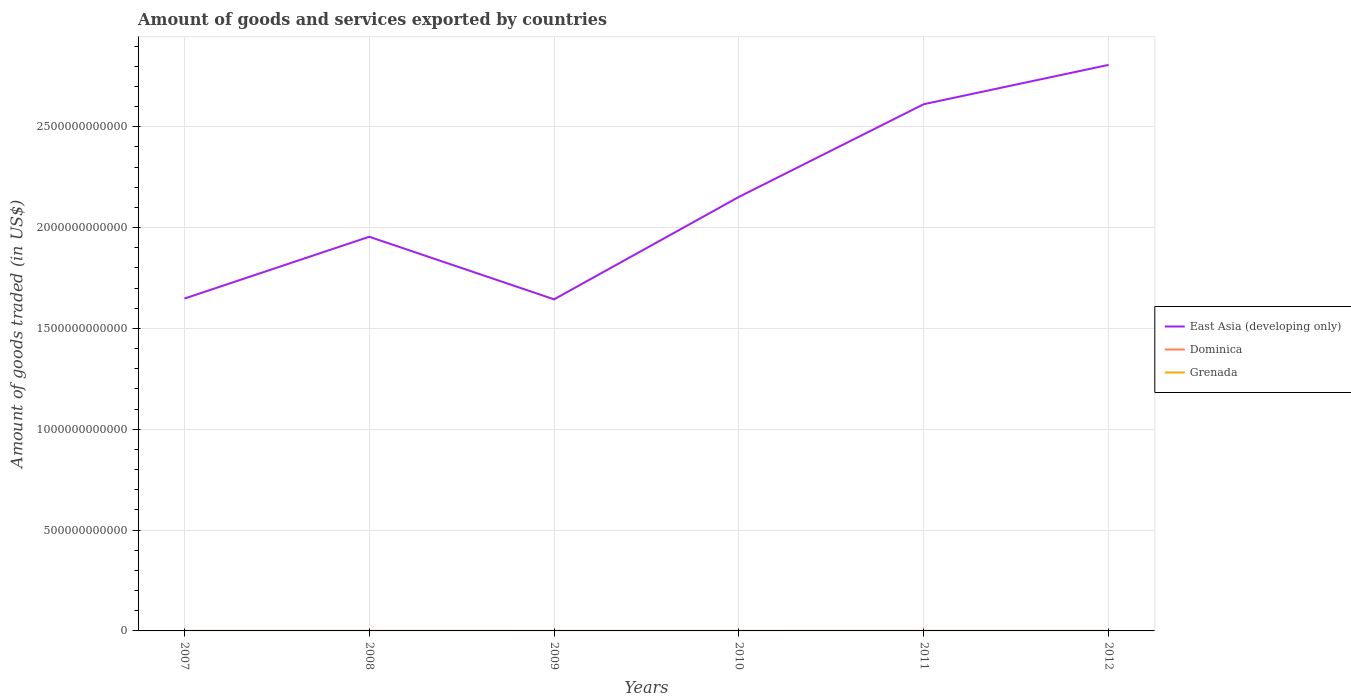Does the line corresponding to East Asia (developing only) intersect with the line corresponding to Grenada?
Your answer should be very brief. No. Is the number of lines equal to the number of legend labels?
Ensure brevity in your answer.  Yes. Across all years, what is the maximum total amount of goods and services exported in Dominica?
Offer a terse response. 3.62e+07. In which year was the total amount of goods and services exported in Dominica maximum?
Give a very brief answer. 2011. What is the total total amount of goods and services exported in East Asia (developing only) in the graph?
Offer a terse response. -4.60e+11. What is the difference between the highest and the second highest total amount of goods and services exported in Grenada?
Give a very brief answer. 1.17e+07. How many lines are there?
Offer a terse response. 3. How many years are there in the graph?
Your answer should be very brief. 6. What is the difference between two consecutive major ticks on the Y-axis?
Make the answer very short. 5.00e+11. Are the values on the major ticks of Y-axis written in scientific E-notation?
Provide a short and direct response. No. How are the legend labels stacked?
Your answer should be very brief. Vertical. What is the title of the graph?
Make the answer very short. Amount of goods and services exported by countries. Does "North America" appear as one of the legend labels in the graph?
Offer a terse response. No. What is the label or title of the Y-axis?
Ensure brevity in your answer.  Amount of goods traded (in US$). What is the Amount of goods traded (in US$) in East Asia (developing only) in 2007?
Provide a short and direct response. 1.65e+12. What is the Amount of goods traded (in US$) in Dominica in 2007?
Provide a succinct answer. 3.90e+07. What is the Amount of goods traded (in US$) of Grenada in 2007?
Offer a terse response. 4.07e+07. What is the Amount of goods traded (in US$) in East Asia (developing only) in 2008?
Your answer should be compact. 1.95e+12. What is the Amount of goods traded (in US$) of Dominica in 2008?
Offer a terse response. 4.39e+07. What is the Amount of goods traded (in US$) of Grenada in 2008?
Your answer should be very brief. 4.05e+07. What is the Amount of goods traded (in US$) of East Asia (developing only) in 2009?
Your response must be concise. 1.64e+12. What is the Amount of goods traded (in US$) in Dominica in 2009?
Make the answer very short. 3.68e+07. What is the Amount of goods traded (in US$) in Grenada in 2009?
Your answer should be compact. 3.53e+07. What is the Amount of goods traded (in US$) in East Asia (developing only) in 2010?
Offer a terse response. 2.15e+12. What is the Amount of goods traded (in US$) of Dominica in 2010?
Provide a short and direct response. 3.72e+07. What is the Amount of goods traded (in US$) of Grenada in 2010?
Your response must be concise. 3.11e+07. What is the Amount of goods traded (in US$) in East Asia (developing only) in 2011?
Keep it short and to the point. 2.61e+12. What is the Amount of goods traded (in US$) of Dominica in 2011?
Make the answer very short. 3.62e+07. What is the Amount of goods traded (in US$) of Grenada in 2011?
Your answer should be very brief. 3.72e+07. What is the Amount of goods traded (in US$) of East Asia (developing only) in 2012?
Make the answer very short. 2.81e+12. What is the Amount of goods traded (in US$) of Dominica in 2012?
Offer a terse response. 3.86e+07. What is the Amount of goods traded (in US$) of Grenada in 2012?
Offer a very short reply. 4.28e+07. Across all years, what is the maximum Amount of goods traded (in US$) in East Asia (developing only)?
Offer a very short reply. 2.81e+12. Across all years, what is the maximum Amount of goods traded (in US$) in Dominica?
Your answer should be very brief. 4.39e+07. Across all years, what is the maximum Amount of goods traded (in US$) of Grenada?
Your answer should be very brief. 4.28e+07. Across all years, what is the minimum Amount of goods traded (in US$) of East Asia (developing only)?
Your answer should be very brief. 1.64e+12. Across all years, what is the minimum Amount of goods traded (in US$) of Dominica?
Your answer should be very brief. 3.62e+07. Across all years, what is the minimum Amount of goods traded (in US$) in Grenada?
Make the answer very short. 3.11e+07. What is the total Amount of goods traded (in US$) in East Asia (developing only) in the graph?
Your answer should be compact. 1.28e+13. What is the total Amount of goods traded (in US$) in Dominica in the graph?
Your response must be concise. 2.32e+08. What is the total Amount of goods traded (in US$) of Grenada in the graph?
Your answer should be compact. 2.28e+08. What is the difference between the Amount of goods traded (in US$) of East Asia (developing only) in 2007 and that in 2008?
Give a very brief answer. -3.07e+11. What is the difference between the Amount of goods traded (in US$) in Dominica in 2007 and that in 2008?
Offer a terse response. -4.87e+06. What is the difference between the Amount of goods traded (in US$) in Grenada in 2007 and that in 2008?
Provide a succinct answer. 2.65e+05. What is the difference between the Amount of goods traded (in US$) in East Asia (developing only) in 2007 and that in 2009?
Ensure brevity in your answer.  3.78e+09. What is the difference between the Amount of goods traded (in US$) in Dominica in 2007 and that in 2009?
Provide a succinct answer. 2.20e+06. What is the difference between the Amount of goods traded (in US$) in Grenada in 2007 and that in 2009?
Offer a very short reply. 5.44e+06. What is the difference between the Amount of goods traded (in US$) of East Asia (developing only) in 2007 and that in 2010?
Provide a short and direct response. -5.04e+11. What is the difference between the Amount of goods traded (in US$) in Dominica in 2007 and that in 2010?
Provide a short and direct response. 1.77e+06. What is the difference between the Amount of goods traded (in US$) in Grenada in 2007 and that in 2010?
Provide a succinct answer. 9.61e+06. What is the difference between the Amount of goods traded (in US$) in East Asia (developing only) in 2007 and that in 2011?
Provide a short and direct response. -9.64e+11. What is the difference between the Amount of goods traded (in US$) in Dominica in 2007 and that in 2011?
Provide a succinct answer. 2.85e+06. What is the difference between the Amount of goods traded (in US$) in Grenada in 2007 and that in 2011?
Your response must be concise. 3.58e+06. What is the difference between the Amount of goods traded (in US$) of East Asia (developing only) in 2007 and that in 2012?
Your response must be concise. -1.16e+12. What is the difference between the Amount of goods traded (in US$) in Dominica in 2007 and that in 2012?
Keep it short and to the point. 4.24e+05. What is the difference between the Amount of goods traded (in US$) in Grenada in 2007 and that in 2012?
Your answer should be compact. -2.08e+06. What is the difference between the Amount of goods traded (in US$) of East Asia (developing only) in 2008 and that in 2009?
Provide a succinct answer. 3.10e+11. What is the difference between the Amount of goods traded (in US$) of Dominica in 2008 and that in 2009?
Keep it short and to the point. 7.07e+06. What is the difference between the Amount of goods traded (in US$) of Grenada in 2008 and that in 2009?
Make the answer very short. 5.17e+06. What is the difference between the Amount of goods traded (in US$) of East Asia (developing only) in 2008 and that in 2010?
Offer a terse response. -1.98e+11. What is the difference between the Amount of goods traded (in US$) of Dominica in 2008 and that in 2010?
Provide a succinct answer. 6.64e+06. What is the difference between the Amount of goods traded (in US$) in Grenada in 2008 and that in 2010?
Ensure brevity in your answer.  9.34e+06. What is the difference between the Amount of goods traded (in US$) in East Asia (developing only) in 2008 and that in 2011?
Provide a short and direct response. -6.57e+11. What is the difference between the Amount of goods traded (in US$) in Dominica in 2008 and that in 2011?
Ensure brevity in your answer.  7.72e+06. What is the difference between the Amount of goods traded (in US$) in Grenada in 2008 and that in 2011?
Your response must be concise. 3.31e+06. What is the difference between the Amount of goods traded (in US$) of East Asia (developing only) in 2008 and that in 2012?
Provide a succinct answer. -8.52e+11. What is the difference between the Amount of goods traded (in US$) in Dominica in 2008 and that in 2012?
Ensure brevity in your answer.  5.29e+06. What is the difference between the Amount of goods traded (in US$) of Grenada in 2008 and that in 2012?
Offer a very short reply. -2.35e+06. What is the difference between the Amount of goods traded (in US$) of East Asia (developing only) in 2009 and that in 2010?
Your response must be concise. -5.08e+11. What is the difference between the Amount of goods traded (in US$) in Dominica in 2009 and that in 2010?
Your answer should be compact. -4.28e+05. What is the difference between the Amount of goods traded (in US$) in Grenada in 2009 and that in 2010?
Offer a terse response. 4.17e+06. What is the difference between the Amount of goods traded (in US$) of East Asia (developing only) in 2009 and that in 2011?
Provide a short and direct response. -9.68e+11. What is the difference between the Amount of goods traded (in US$) of Dominica in 2009 and that in 2011?
Keep it short and to the point. 6.46e+05. What is the difference between the Amount of goods traded (in US$) in Grenada in 2009 and that in 2011?
Your answer should be very brief. -1.86e+06. What is the difference between the Amount of goods traded (in US$) of East Asia (developing only) in 2009 and that in 2012?
Offer a terse response. -1.16e+12. What is the difference between the Amount of goods traded (in US$) of Dominica in 2009 and that in 2012?
Provide a succinct answer. -1.78e+06. What is the difference between the Amount of goods traded (in US$) in Grenada in 2009 and that in 2012?
Provide a short and direct response. -7.52e+06. What is the difference between the Amount of goods traded (in US$) of East Asia (developing only) in 2010 and that in 2011?
Provide a succinct answer. -4.60e+11. What is the difference between the Amount of goods traded (in US$) in Dominica in 2010 and that in 2011?
Ensure brevity in your answer.  1.07e+06. What is the difference between the Amount of goods traded (in US$) of Grenada in 2010 and that in 2011?
Provide a succinct answer. -6.03e+06. What is the difference between the Amount of goods traded (in US$) in East Asia (developing only) in 2010 and that in 2012?
Your answer should be compact. -6.55e+11. What is the difference between the Amount of goods traded (in US$) in Dominica in 2010 and that in 2012?
Provide a succinct answer. -1.35e+06. What is the difference between the Amount of goods traded (in US$) of Grenada in 2010 and that in 2012?
Your answer should be compact. -1.17e+07. What is the difference between the Amount of goods traded (in US$) in East Asia (developing only) in 2011 and that in 2012?
Provide a succinct answer. -1.95e+11. What is the difference between the Amount of goods traded (in US$) in Dominica in 2011 and that in 2012?
Offer a terse response. -2.43e+06. What is the difference between the Amount of goods traded (in US$) in Grenada in 2011 and that in 2012?
Your answer should be very brief. -5.66e+06. What is the difference between the Amount of goods traded (in US$) of East Asia (developing only) in 2007 and the Amount of goods traded (in US$) of Dominica in 2008?
Ensure brevity in your answer.  1.65e+12. What is the difference between the Amount of goods traded (in US$) of East Asia (developing only) in 2007 and the Amount of goods traded (in US$) of Grenada in 2008?
Your answer should be compact. 1.65e+12. What is the difference between the Amount of goods traded (in US$) in Dominica in 2007 and the Amount of goods traded (in US$) in Grenada in 2008?
Your answer should be very brief. -1.45e+06. What is the difference between the Amount of goods traded (in US$) in East Asia (developing only) in 2007 and the Amount of goods traded (in US$) in Dominica in 2009?
Offer a very short reply. 1.65e+12. What is the difference between the Amount of goods traded (in US$) of East Asia (developing only) in 2007 and the Amount of goods traded (in US$) of Grenada in 2009?
Offer a very short reply. 1.65e+12. What is the difference between the Amount of goods traded (in US$) of Dominica in 2007 and the Amount of goods traded (in US$) of Grenada in 2009?
Your response must be concise. 3.73e+06. What is the difference between the Amount of goods traded (in US$) in East Asia (developing only) in 2007 and the Amount of goods traded (in US$) in Dominica in 2010?
Your answer should be very brief. 1.65e+12. What is the difference between the Amount of goods traded (in US$) of East Asia (developing only) in 2007 and the Amount of goods traded (in US$) of Grenada in 2010?
Your answer should be very brief. 1.65e+12. What is the difference between the Amount of goods traded (in US$) in Dominica in 2007 and the Amount of goods traded (in US$) in Grenada in 2010?
Provide a succinct answer. 7.89e+06. What is the difference between the Amount of goods traded (in US$) of East Asia (developing only) in 2007 and the Amount of goods traded (in US$) of Dominica in 2011?
Make the answer very short. 1.65e+12. What is the difference between the Amount of goods traded (in US$) in East Asia (developing only) in 2007 and the Amount of goods traded (in US$) in Grenada in 2011?
Your response must be concise. 1.65e+12. What is the difference between the Amount of goods traded (in US$) of Dominica in 2007 and the Amount of goods traded (in US$) of Grenada in 2011?
Make the answer very short. 1.86e+06. What is the difference between the Amount of goods traded (in US$) in East Asia (developing only) in 2007 and the Amount of goods traded (in US$) in Dominica in 2012?
Your answer should be compact. 1.65e+12. What is the difference between the Amount of goods traded (in US$) of East Asia (developing only) in 2007 and the Amount of goods traded (in US$) of Grenada in 2012?
Offer a terse response. 1.65e+12. What is the difference between the Amount of goods traded (in US$) of Dominica in 2007 and the Amount of goods traded (in US$) of Grenada in 2012?
Provide a succinct answer. -3.80e+06. What is the difference between the Amount of goods traded (in US$) of East Asia (developing only) in 2008 and the Amount of goods traded (in US$) of Dominica in 2009?
Your answer should be very brief. 1.95e+12. What is the difference between the Amount of goods traded (in US$) in East Asia (developing only) in 2008 and the Amount of goods traded (in US$) in Grenada in 2009?
Make the answer very short. 1.95e+12. What is the difference between the Amount of goods traded (in US$) in Dominica in 2008 and the Amount of goods traded (in US$) in Grenada in 2009?
Offer a very short reply. 8.59e+06. What is the difference between the Amount of goods traded (in US$) in East Asia (developing only) in 2008 and the Amount of goods traded (in US$) in Dominica in 2010?
Keep it short and to the point. 1.95e+12. What is the difference between the Amount of goods traded (in US$) in East Asia (developing only) in 2008 and the Amount of goods traded (in US$) in Grenada in 2010?
Your answer should be very brief. 1.95e+12. What is the difference between the Amount of goods traded (in US$) of Dominica in 2008 and the Amount of goods traded (in US$) of Grenada in 2010?
Your answer should be very brief. 1.28e+07. What is the difference between the Amount of goods traded (in US$) of East Asia (developing only) in 2008 and the Amount of goods traded (in US$) of Dominica in 2011?
Give a very brief answer. 1.95e+12. What is the difference between the Amount of goods traded (in US$) in East Asia (developing only) in 2008 and the Amount of goods traded (in US$) in Grenada in 2011?
Provide a short and direct response. 1.95e+12. What is the difference between the Amount of goods traded (in US$) in Dominica in 2008 and the Amount of goods traded (in US$) in Grenada in 2011?
Give a very brief answer. 6.73e+06. What is the difference between the Amount of goods traded (in US$) in East Asia (developing only) in 2008 and the Amount of goods traded (in US$) in Dominica in 2012?
Your answer should be very brief. 1.95e+12. What is the difference between the Amount of goods traded (in US$) in East Asia (developing only) in 2008 and the Amount of goods traded (in US$) in Grenada in 2012?
Make the answer very short. 1.95e+12. What is the difference between the Amount of goods traded (in US$) in Dominica in 2008 and the Amount of goods traded (in US$) in Grenada in 2012?
Make the answer very short. 1.07e+06. What is the difference between the Amount of goods traded (in US$) in East Asia (developing only) in 2009 and the Amount of goods traded (in US$) in Dominica in 2010?
Your response must be concise. 1.64e+12. What is the difference between the Amount of goods traded (in US$) of East Asia (developing only) in 2009 and the Amount of goods traded (in US$) of Grenada in 2010?
Make the answer very short. 1.64e+12. What is the difference between the Amount of goods traded (in US$) of Dominica in 2009 and the Amount of goods traded (in US$) of Grenada in 2010?
Give a very brief answer. 5.69e+06. What is the difference between the Amount of goods traded (in US$) of East Asia (developing only) in 2009 and the Amount of goods traded (in US$) of Dominica in 2011?
Make the answer very short. 1.64e+12. What is the difference between the Amount of goods traded (in US$) in East Asia (developing only) in 2009 and the Amount of goods traded (in US$) in Grenada in 2011?
Provide a succinct answer. 1.64e+12. What is the difference between the Amount of goods traded (in US$) of Dominica in 2009 and the Amount of goods traded (in US$) of Grenada in 2011?
Provide a succinct answer. -3.38e+05. What is the difference between the Amount of goods traded (in US$) in East Asia (developing only) in 2009 and the Amount of goods traded (in US$) in Dominica in 2012?
Make the answer very short. 1.64e+12. What is the difference between the Amount of goods traded (in US$) in East Asia (developing only) in 2009 and the Amount of goods traded (in US$) in Grenada in 2012?
Give a very brief answer. 1.64e+12. What is the difference between the Amount of goods traded (in US$) of Dominica in 2009 and the Amount of goods traded (in US$) of Grenada in 2012?
Provide a succinct answer. -6.00e+06. What is the difference between the Amount of goods traded (in US$) in East Asia (developing only) in 2010 and the Amount of goods traded (in US$) in Dominica in 2011?
Offer a very short reply. 2.15e+12. What is the difference between the Amount of goods traded (in US$) of East Asia (developing only) in 2010 and the Amount of goods traded (in US$) of Grenada in 2011?
Provide a short and direct response. 2.15e+12. What is the difference between the Amount of goods traded (in US$) in Dominica in 2010 and the Amount of goods traded (in US$) in Grenada in 2011?
Your response must be concise. 8.99e+04. What is the difference between the Amount of goods traded (in US$) in East Asia (developing only) in 2010 and the Amount of goods traded (in US$) in Dominica in 2012?
Give a very brief answer. 2.15e+12. What is the difference between the Amount of goods traded (in US$) in East Asia (developing only) in 2010 and the Amount of goods traded (in US$) in Grenada in 2012?
Make the answer very short. 2.15e+12. What is the difference between the Amount of goods traded (in US$) of Dominica in 2010 and the Amount of goods traded (in US$) of Grenada in 2012?
Make the answer very short. -5.57e+06. What is the difference between the Amount of goods traded (in US$) in East Asia (developing only) in 2011 and the Amount of goods traded (in US$) in Dominica in 2012?
Make the answer very short. 2.61e+12. What is the difference between the Amount of goods traded (in US$) in East Asia (developing only) in 2011 and the Amount of goods traded (in US$) in Grenada in 2012?
Your answer should be compact. 2.61e+12. What is the difference between the Amount of goods traded (in US$) of Dominica in 2011 and the Amount of goods traded (in US$) of Grenada in 2012?
Make the answer very short. -6.64e+06. What is the average Amount of goods traded (in US$) of East Asia (developing only) per year?
Your answer should be very brief. 2.14e+12. What is the average Amount of goods traded (in US$) of Dominica per year?
Give a very brief answer. 3.86e+07. What is the average Amount of goods traded (in US$) of Grenada per year?
Provide a short and direct response. 3.79e+07. In the year 2007, what is the difference between the Amount of goods traded (in US$) in East Asia (developing only) and Amount of goods traded (in US$) in Dominica?
Your answer should be compact. 1.65e+12. In the year 2007, what is the difference between the Amount of goods traded (in US$) in East Asia (developing only) and Amount of goods traded (in US$) in Grenada?
Give a very brief answer. 1.65e+12. In the year 2007, what is the difference between the Amount of goods traded (in US$) in Dominica and Amount of goods traded (in US$) in Grenada?
Your answer should be compact. -1.71e+06. In the year 2008, what is the difference between the Amount of goods traded (in US$) in East Asia (developing only) and Amount of goods traded (in US$) in Dominica?
Your response must be concise. 1.95e+12. In the year 2008, what is the difference between the Amount of goods traded (in US$) of East Asia (developing only) and Amount of goods traded (in US$) of Grenada?
Offer a very short reply. 1.95e+12. In the year 2008, what is the difference between the Amount of goods traded (in US$) of Dominica and Amount of goods traded (in US$) of Grenada?
Make the answer very short. 3.42e+06. In the year 2009, what is the difference between the Amount of goods traded (in US$) of East Asia (developing only) and Amount of goods traded (in US$) of Dominica?
Keep it short and to the point. 1.64e+12. In the year 2009, what is the difference between the Amount of goods traded (in US$) in East Asia (developing only) and Amount of goods traded (in US$) in Grenada?
Keep it short and to the point. 1.64e+12. In the year 2009, what is the difference between the Amount of goods traded (in US$) in Dominica and Amount of goods traded (in US$) in Grenada?
Give a very brief answer. 1.52e+06. In the year 2010, what is the difference between the Amount of goods traded (in US$) in East Asia (developing only) and Amount of goods traded (in US$) in Dominica?
Offer a very short reply. 2.15e+12. In the year 2010, what is the difference between the Amount of goods traded (in US$) of East Asia (developing only) and Amount of goods traded (in US$) of Grenada?
Keep it short and to the point. 2.15e+12. In the year 2010, what is the difference between the Amount of goods traded (in US$) of Dominica and Amount of goods traded (in US$) of Grenada?
Provide a succinct answer. 6.12e+06. In the year 2011, what is the difference between the Amount of goods traded (in US$) in East Asia (developing only) and Amount of goods traded (in US$) in Dominica?
Keep it short and to the point. 2.61e+12. In the year 2011, what is the difference between the Amount of goods traded (in US$) in East Asia (developing only) and Amount of goods traded (in US$) in Grenada?
Provide a short and direct response. 2.61e+12. In the year 2011, what is the difference between the Amount of goods traded (in US$) in Dominica and Amount of goods traded (in US$) in Grenada?
Your answer should be very brief. -9.84e+05. In the year 2012, what is the difference between the Amount of goods traded (in US$) in East Asia (developing only) and Amount of goods traded (in US$) in Dominica?
Make the answer very short. 2.81e+12. In the year 2012, what is the difference between the Amount of goods traded (in US$) in East Asia (developing only) and Amount of goods traded (in US$) in Grenada?
Your answer should be very brief. 2.81e+12. In the year 2012, what is the difference between the Amount of goods traded (in US$) of Dominica and Amount of goods traded (in US$) of Grenada?
Keep it short and to the point. -4.22e+06. What is the ratio of the Amount of goods traded (in US$) of East Asia (developing only) in 2007 to that in 2008?
Your answer should be compact. 0.84. What is the ratio of the Amount of goods traded (in US$) of Dominica in 2007 to that in 2008?
Make the answer very short. 0.89. What is the ratio of the Amount of goods traded (in US$) in Grenada in 2007 to that in 2008?
Provide a succinct answer. 1.01. What is the ratio of the Amount of goods traded (in US$) of East Asia (developing only) in 2007 to that in 2009?
Give a very brief answer. 1. What is the ratio of the Amount of goods traded (in US$) of Dominica in 2007 to that in 2009?
Provide a succinct answer. 1.06. What is the ratio of the Amount of goods traded (in US$) in Grenada in 2007 to that in 2009?
Make the answer very short. 1.15. What is the ratio of the Amount of goods traded (in US$) of East Asia (developing only) in 2007 to that in 2010?
Offer a terse response. 0.77. What is the ratio of the Amount of goods traded (in US$) in Dominica in 2007 to that in 2010?
Provide a succinct answer. 1.05. What is the ratio of the Amount of goods traded (in US$) in Grenada in 2007 to that in 2010?
Ensure brevity in your answer.  1.31. What is the ratio of the Amount of goods traded (in US$) of East Asia (developing only) in 2007 to that in 2011?
Offer a terse response. 0.63. What is the ratio of the Amount of goods traded (in US$) in Dominica in 2007 to that in 2011?
Offer a very short reply. 1.08. What is the ratio of the Amount of goods traded (in US$) of Grenada in 2007 to that in 2011?
Your answer should be very brief. 1.1. What is the ratio of the Amount of goods traded (in US$) of East Asia (developing only) in 2007 to that in 2012?
Your answer should be compact. 0.59. What is the ratio of the Amount of goods traded (in US$) in Dominica in 2007 to that in 2012?
Your answer should be very brief. 1.01. What is the ratio of the Amount of goods traded (in US$) of Grenada in 2007 to that in 2012?
Keep it short and to the point. 0.95. What is the ratio of the Amount of goods traded (in US$) of East Asia (developing only) in 2008 to that in 2009?
Your answer should be very brief. 1.19. What is the ratio of the Amount of goods traded (in US$) of Dominica in 2008 to that in 2009?
Your answer should be compact. 1.19. What is the ratio of the Amount of goods traded (in US$) of Grenada in 2008 to that in 2009?
Offer a terse response. 1.15. What is the ratio of the Amount of goods traded (in US$) of East Asia (developing only) in 2008 to that in 2010?
Give a very brief answer. 0.91. What is the ratio of the Amount of goods traded (in US$) of Dominica in 2008 to that in 2010?
Ensure brevity in your answer.  1.18. What is the ratio of the Amount of goods traded (in US$) in Grenada in 2008 to that in 2010?
Your answer should be very brief. 1.3. What is the ratio of the Amount of goods traded (in US$) in East Asia (developing only) in 2008 to that in 2011?
Ensure brevity in your answer.  0.75. What is the ratio of the Amount of goods traded (in US$) in Dominica in 2008 to that in 2011?
Your response must be concise. 1.21. What is the ratio of the Amount of goods traded (in US$) of Grenada in 2008 to that in 2011?
Your answer should be compact. 1.09. What is the ratio of the Amount of goods traded (in US$) in East Asia (developing only) in 2008 to that in 2012?
Offer a very short reply. 0.7. What is the ratio of the Amount of goods traded (in US$) of Dominica in 2008 to that in 2012?
Your answer should be compact. 1.14. What is the ratio of the Amount of goods traded (in US$) in Grenada in 2008 to that in 2012?
Offer a terse response. 0.95. What is the ratio of the Amount of goods traded (in US$) in East Asia (developing only) in 2009 to that in 2010?
Make the answer very short. 0.76. What is the ratio of the Amount of goods traded (in US$) of Grenada in 2009 to that in 2010?
Ensure brevity in your answer.  1.13. What is the ratio of the Amount of goods traded (in US$) of East Asia (developing only) in 2009 to that in 2011?
Your response must be concise. 0.63. What is the ratio of the Amount of goods traded (in US$) in Dominica in 2009 to that in 2011?
Ensure brevity in your answer.  1.02. What is the ratio of the Amount of goods traded (in US$) of Grenada in 2009 to that in 2011?
Your answer should be compact. 0.95. What is the ratio of the Amount of goods traded (in US$) in East Asia (developing only) in 2009 to that in 2012?
Offer a very short reply. 0.59. What is the ratio of the Amount of goods traded (in US$) in Dominica in 2009 to that in 2012?
Offer a terse response. 0.95. What is the ratio of the Amount of goods traded (in US$) in Grenada in 2009 to that in 2012?
Your answer should be very brief. 0.82. What is the ratio of the Amount of goods traded (in US$) in East Asia (developing only) in 2010 to that in 2011?
Provide a succinct answer. 0.82. What is the ratio of the Amount of goods traded (in US$) in Dominica in 2010 to that in 2011?
Your answer should be compact. 1.03. What is the ratio of the Amount of goods traded (in US$) in Grenada in 2010 to that in 2011?
Provide a short and direct response. 0.84. What is the ratio of the Amount of goods traded (in US$) in East Asia (developing only) in 2010 to that in 2012?
Make the answer very short. 0.77. What is the ratio of the Amount of goods traded (in US$) in Grenada in 2010 to that in 2012?
Offer a very short reply. 0.73. What is the ratio of the Amount of goods traded (in US$) of East Asia (developing only) in 2011 to that in 2012?
Your response must be concise. 0.93. What is the ratio of the Amount of goods traded (in US$) in Dominica in 2011 to that in 2012?
Your answer should be very brief. 0.94. What is the ratio of the Amount of goods traded (in US$) of Grenada in 2011 to that in 2012?
Make the answer very short. 0.87. What is the difference between the highest and the second highest Amount of goods traded (in US$) of East Asia (developing only)?
Provide a succinct answer. 1.95e+11. What is the difference between the highest and the second highest Amount of goods traded (in US$) in Dominica?
Your response must be concise. 4.87e+06. What is the difference between the highest and the second highest Amount of goods traded (in US$) in Grenada?
Your answer should be very brief. 2.08e+06. What is the difference between the highest and the lowest Amount of goods traded (in US$) in East Asia (developing only)?
Make the answer very short. 1.16e+12. What is the difference between the highest and the lowest Amount of goods traded (in US$) in Dominica?
Your answer should be very brief. 7.72e+06. What is the difference between the highest and the lowest Amount of goods traded (in US$) in Grenada?
Make the answer very short. 1.17e+07. 